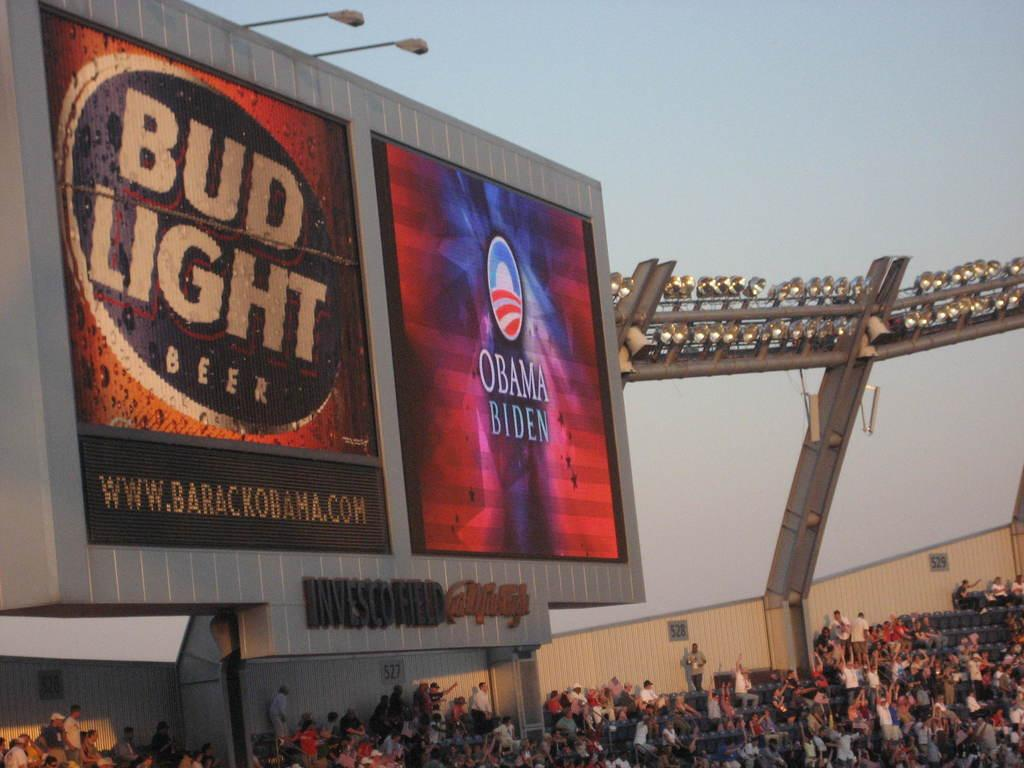<image>
Present a compact description of the photo's key features. Bud light beer and a obama sign on a board with people looking at it 